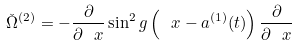Convert formula to latex. <formula><loc_0><loc_0><loc_500><loc_500>\check { \Omega } ^ { ( 2 ) } = - \frac { \partial } { \partial \ x } \sin ^ { 2 } g \left ( \ x - a ^ { ( 1 ) } ( t ) \right ) \frac { \partial } { \partial \ x }</formula> 